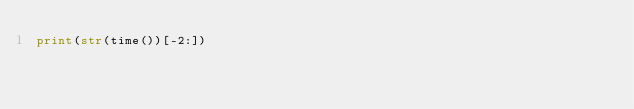<code> <loc_0><loc_0><loc_500><loc_500><_Python_>print(str(time())[-2:])</code> 